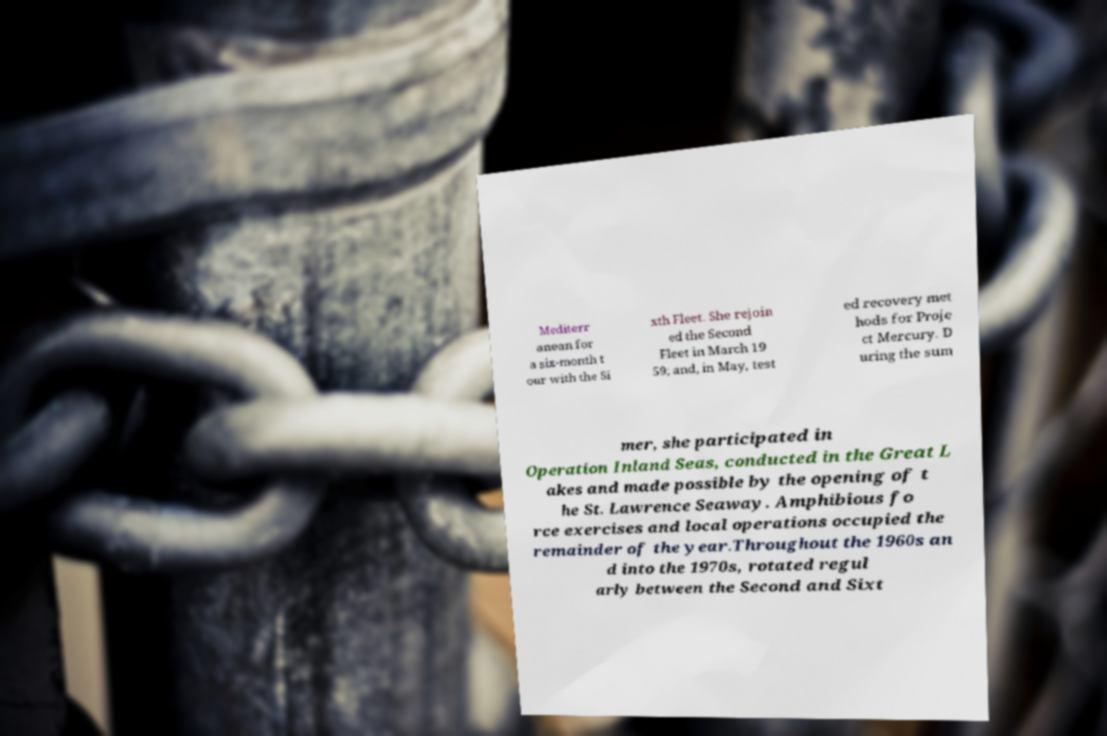Can you accurately transcribe the text from the provided image for me? Mediterr anean for a six-month t our with the Si xth Fleet. She rejoin ed the Second Fleet in March 19 59; and, in May, test ed recovery met hods for Proje ct Mercury. D uring the sum mer, she participated in Operation Inland Seas, conducted in the Great L akes and made possible by the opening of t he St. Lawrence Seaway. Amphibious fo rce exercises and local operations occupied the remainder of the year.Throughout the 1960s an d into the 1970s, rotated regul arly between the Second and Sixt 